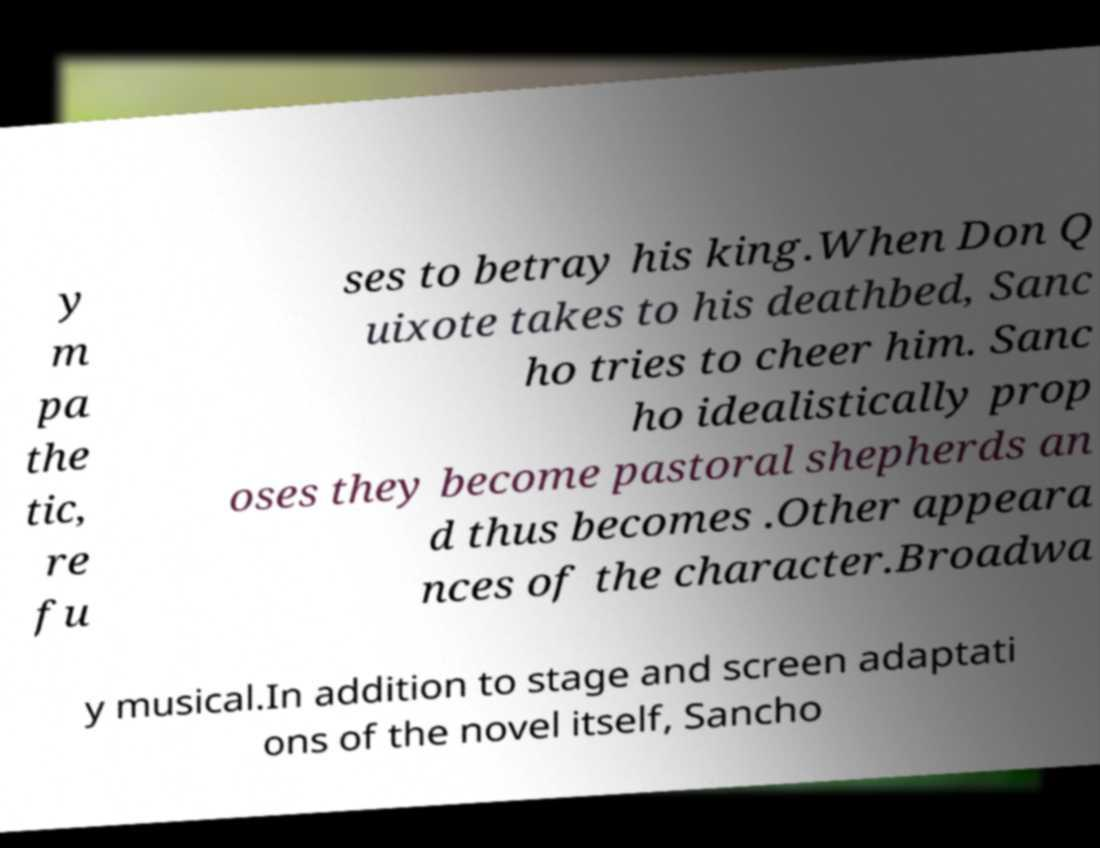There's text embedded in this image that I need extracted. Can you transcribe it verbatim? y m pa the tic, re fu ses to betray his king.When Don Q uixote takes to his deathbed, Sanc ho tries to cheer him. Sanc ho idealistically prop oses they become pastoral shepherds an d thus becomes .Other appeara nces of the character.Broadwa y musical.In addition to stage and screen adaptati ons of the novel itself, Sancho 